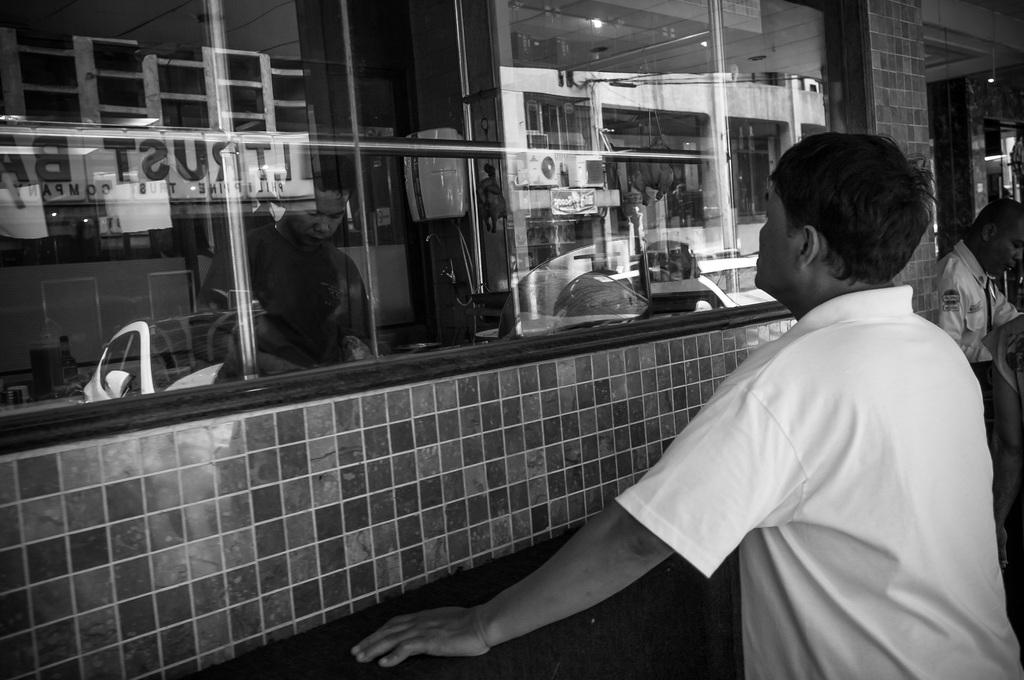How many persons are visible in the image? There are persons standing in the image. What is located behind the persons in the image? There is a wall in the image. What are the rods used for in the image? The purpose of the rods is not specified in the image. What device is present for cooling in the image? There is an AC (air conditioner) in the image. What is the name board used for in the image? The name board is likely used for identification purposes. What type of illumination is present in the image? There are lights in the image. Can you describe any other objects in the image? There are some objects in the image, but their specific nature is not mentioned in the facts. Can you see any rabbits playing in the image? There are no rabbits present in the image. What type of pleasure can be seen being experienced by the persons in the image? The image does not provide any information about the emotions or experiences of the persons. 